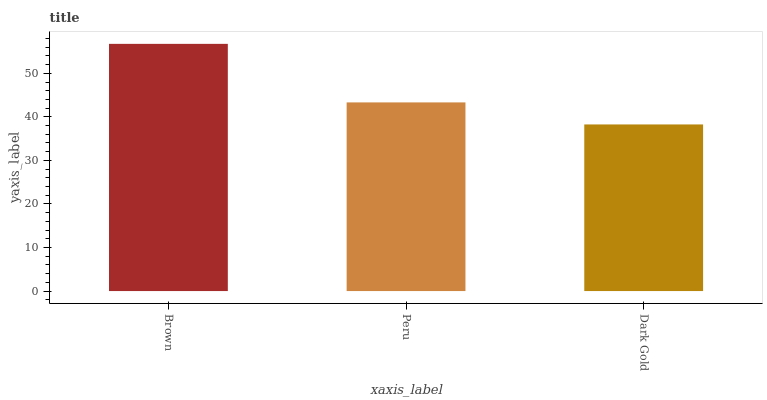Is Dark Gold the minimum?
Answer yes or no. Yes. Is Brown the maximum?
Answer yes or no. Yes. Is Peru the minimum?
Answer yes or no. No. Is Peru the maximum?
Answer yes or no. No. Is Brown greater than Peru?
Answer yes or no. Yes. Is Peru less than Brown?
Answer yes or no. Yes. Is Peru greater than Brown?
Answer yes or no. No. Is Brown less than Peru?
Answer yes or no. No. Is Peru the high median?
Answer yes or no. Yes. Is Peru the low median?
Answer yes or no. Yes. Is Dark Gold the high median?
Answer yes or no. No. Is Dark Gold the low median?
Answer yes or no. No. 